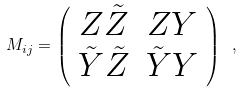<formula> <loc_0><loc_0><loc_500><loc_500>M _ { i j } = \left ( \begin{array} [ ] { c c } Z \tilde { Z } & Z Y \\ \tilde { Y } \tilde { Z } & \tilde { Y } Y \end{array} \right ) \ ,</formula> 